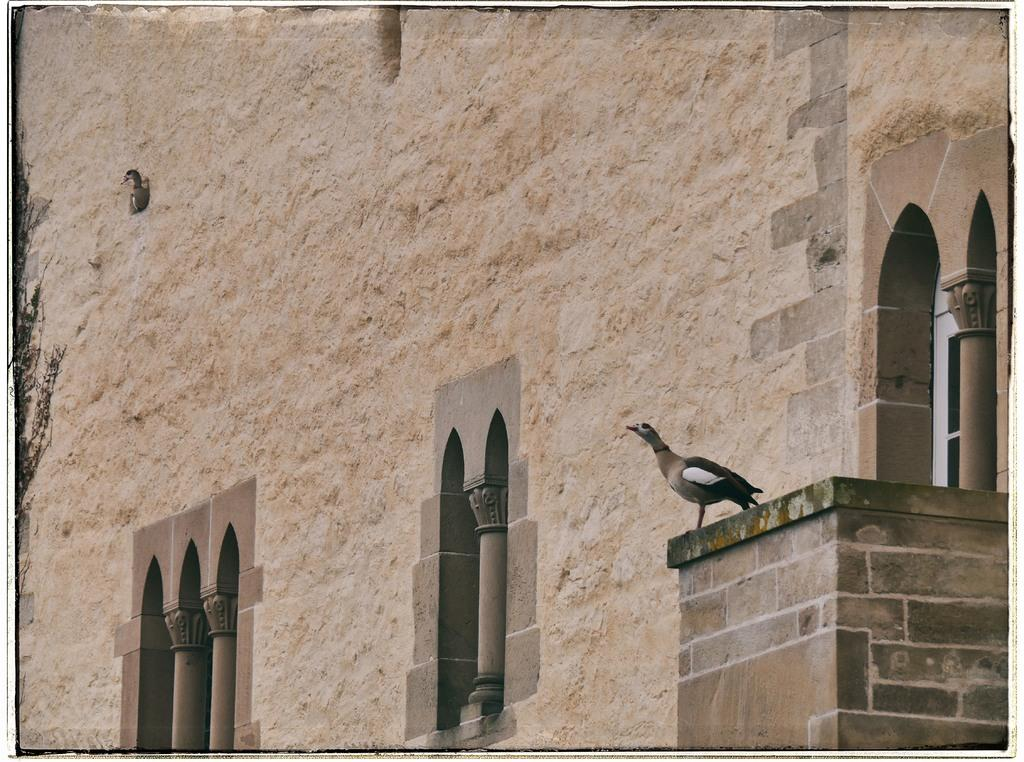What type of structure can be seen in the image? There is a wall and pillars in the image, suggesting a building or architectural structure. What type of material might the window be made of? The glass window in the image is likely made of glass. How many birds are visible in the image? There are two birds visible in the image. What type of market is visible in the image? There is no market present in the image. What type of mark can be seen on the wall in the image? There is no mark visible on the wall in the image. 